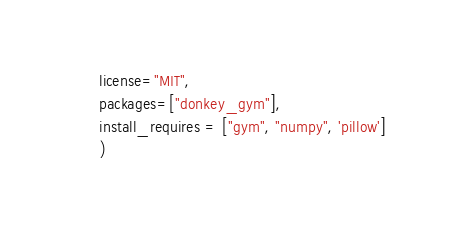Convert code to text. <code><loc_0><loc_0><loc_500><loc_500><_Python_>      license="MIT",
      packages=["donkey_gym"],
      install_requires = ["gym", "numpy", 'pillow']
      )
</code> 